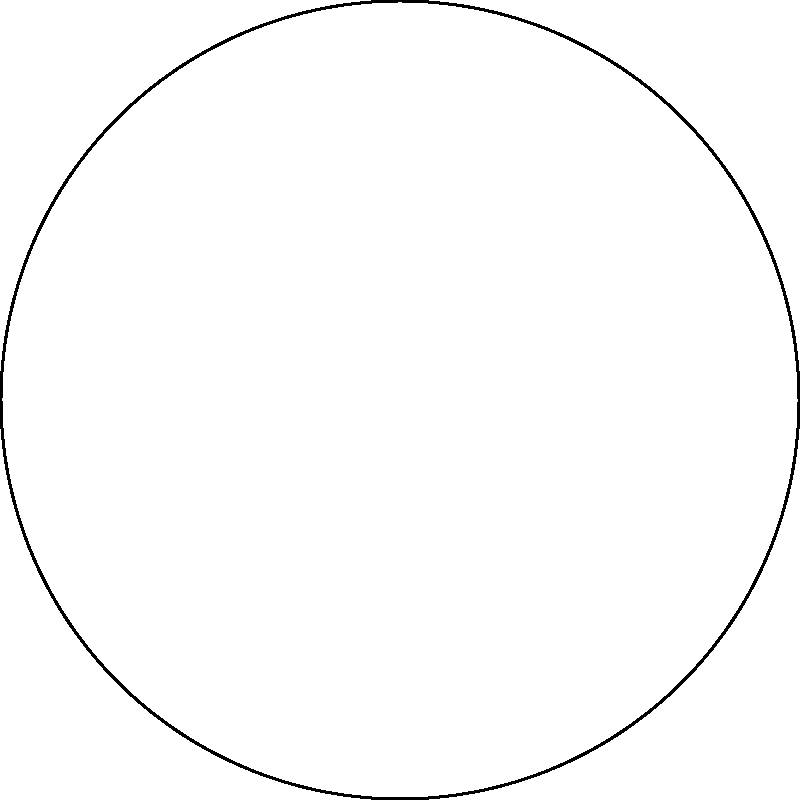In a circular museum rotunda, 8 sculptures are arranged equidistantly around the perimeter. Using polar coordinates, where the radius is 5 meters and the angle is measured counterclockwise from the positive x-axis, what are the coordinates of the sculpture located at 135°? To find the polar coordinates of the sculpture at 135°, we need to follow these steps:

1. Identify the given information:
   - The radius of the rotunda is 5 meters
   - The angle is 135°

2. Recall the format of polar coordinates: $(r, \theta)$
   Where:
   $r$ = radius (distance from the origin)
   $\theta$ = angle (measured counterclockwise from the positive x-axis)

3. In this case:
   $r = 5$ (given)
   $\theta = 135°$

4. Convert the angle to radians (optional, but often preferred in mathematical notation):
   $135° = 135 \times \frac{\pi}{180} = \frac{3\pi}{4}$ radians

5. Express the final answer in polar coordinates:
   $(5, 135°)$ or $(5, \frac{3\pi}{4})$

Both forms are correct, but in mathematical contexts, the radian measure is often preferred.
Answer: $(5, \frac{3\pi}{4})$ 